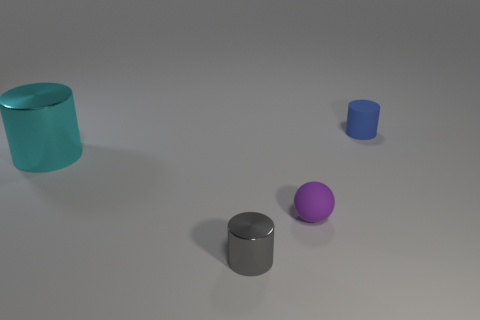What number of other objects are there of the same color as the tiny matte sphere?
Your response must be concise. 0. There is a tiny rubber cylinder; is its color the same as the metallic cylinder right of the cyan metallic object?
Your answer should be very brief. No. What number of cylinders are left of the matte object that is left of the blue matte object?
Ensure brevity in your answer.  2. Is there any other thing that has the same material as the small gray thing?
Ensure brevity in your answer.  Yes. What is the cylinder that is on the left side of the shiny object in front of the tiny purple thing that is on the right side of the big cyan cylinder made of?
Offer a very short reply. Metal. What is the material of the small thing that is behind the gray thing and in front of the blue cylinder?
Provide a succinct answer. Rubber. How many blue matte things have the same shape as the big cyan metallic thing?
Your answer should be compact. 1. What is the size of the cyan metallic cylinder to the left of the tiny rubber thing in front of the large metallic object?
Keep it short and to the point. Large. Do the small object that is right of the tiny purple ball and the metallic cylinder to the right of the cyan object have the same color?
Make the answer very short. No. There is a shiny thing that is left of the tiny gray object in front of the small blue cylinder; what number of things are in front of it?
Ensure brevity in your answer.  2. 